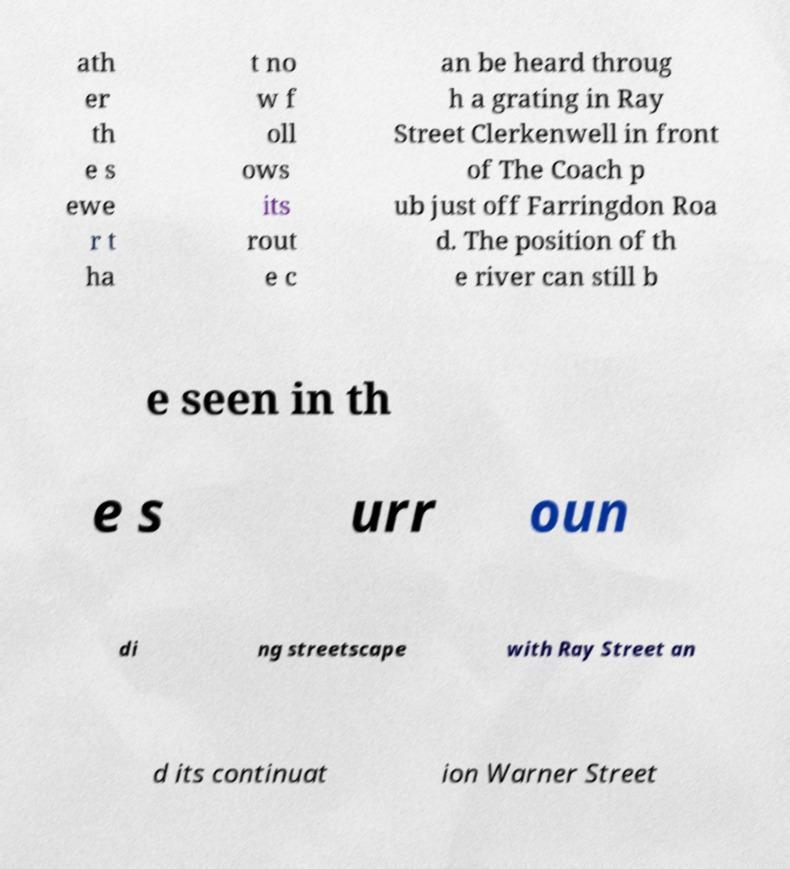Could you assist in decoding the text presented in this image and type it out clearly? ath er th e s ewe r t ha t no w f oll ows its rout e c an be heard throug h a grating in Ray Street Clerkenwell in front of The Coach p ub just off Farringdon Roa d. The position of th e river can still b e seen in th e s urr oun di ng streetscape with Ray Street an d its continuat ion Warner Street 